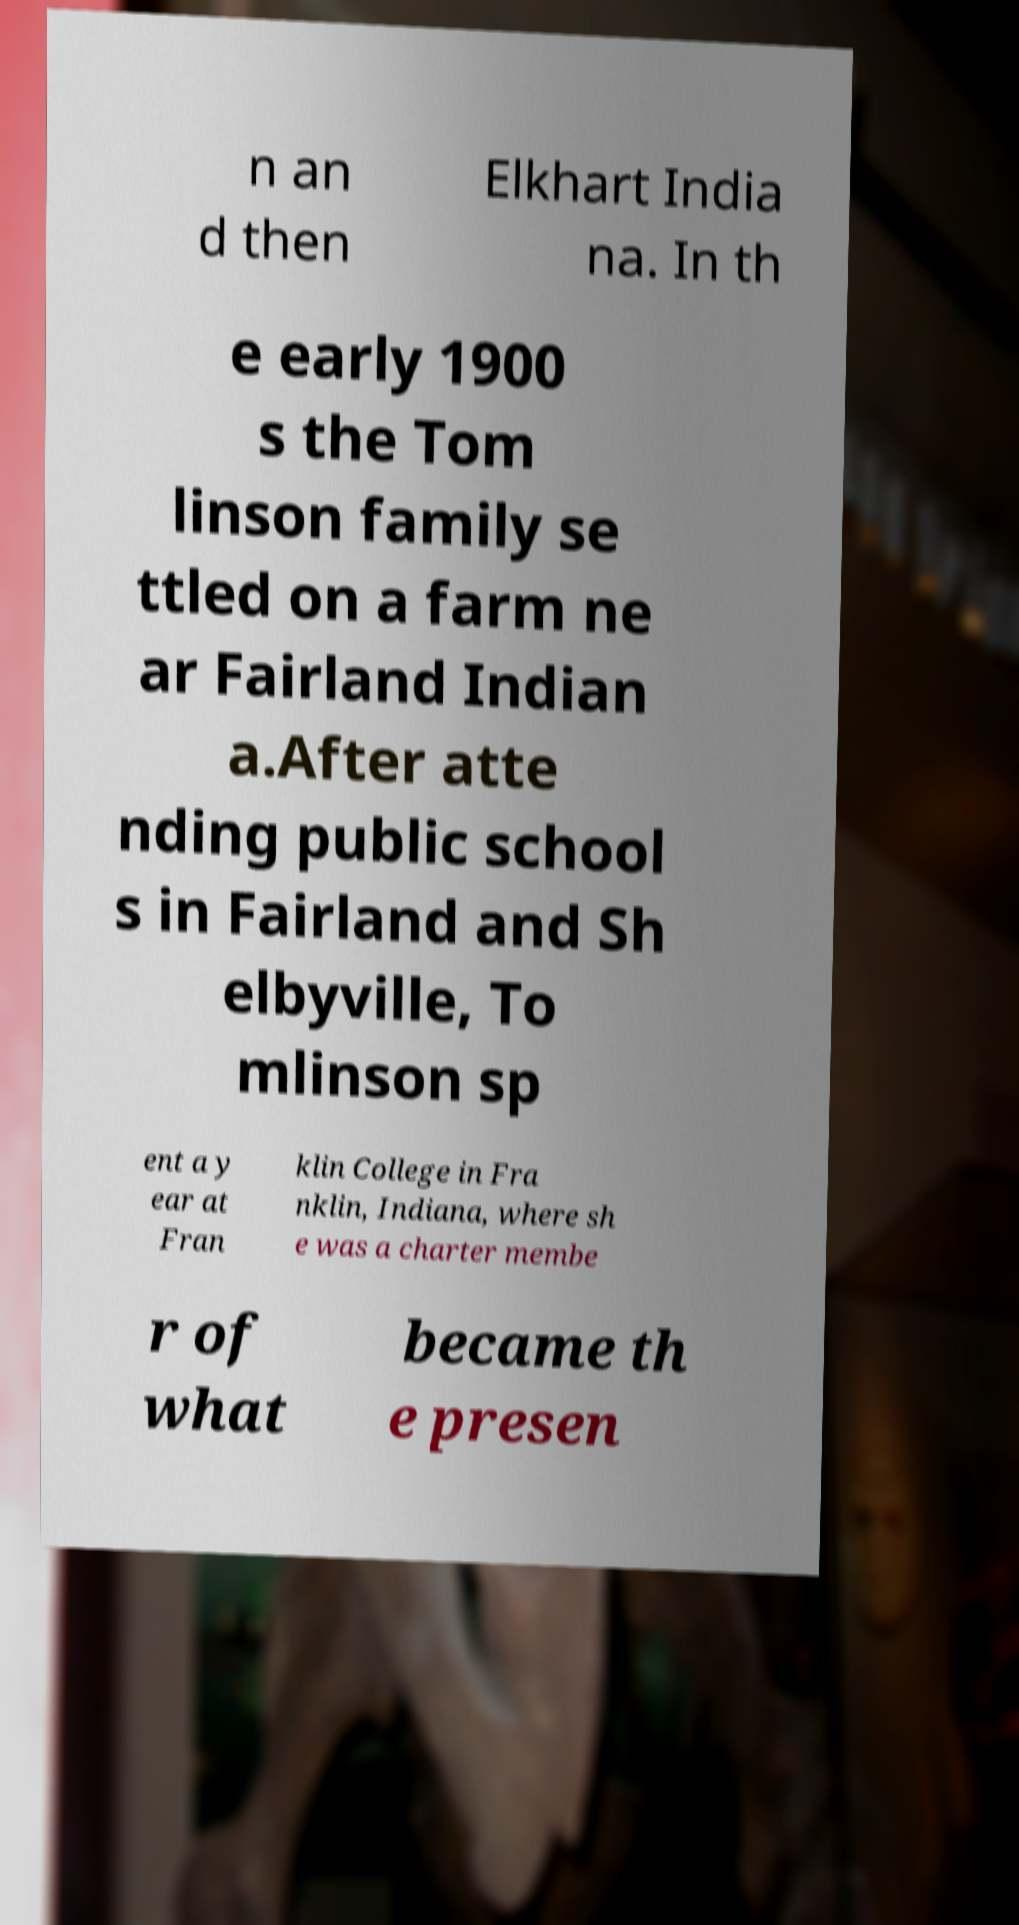Can you read and provide the text displayed in the image?This photo seems to have some interesting text. Can you extract and type it out for me? n an d then Elkhart India na. In th e early 1900 s the Tom linson family se ttled on a farm ne ar Fairland Indian a.After atte nding public school s in Fairland and Sh elbyville, To mlinson sp ent a y ear at Fran klin College in Fra nklin, Indiana, where sh e was a charter membe r of what became th e presen 